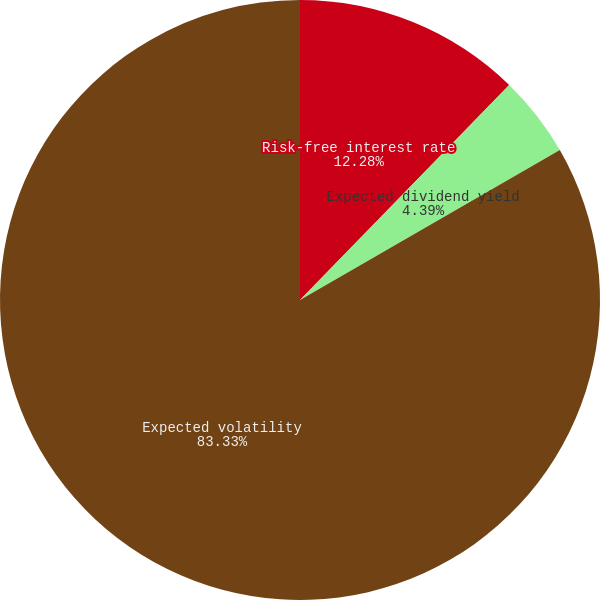Convert chart to OTSL. <chart><loc_0><loc_0><loc_500><loc_500><pie_chart><fcel>Risk-free interest rate<fcel>Expected dividend yield<fcel>Expected volatility<nl><fcel>12.28%<fcel>4.39%<fcel>83.33%<nl></chart> 